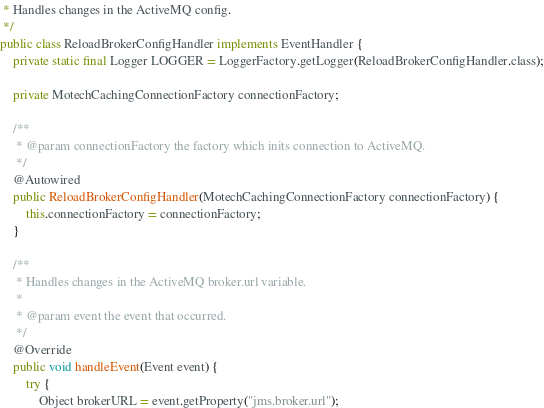<code> <loc_0><loc_0><loc_500><loc_500><_Java_> * Handles changes in the ActiveMQ config.
 */
public class ReloadBrokerConfigHandler implements EventHandler {
    private static final Logger LOGGER = LoggerFactory.getLogger(ReloadBrokerConfigHandler.class);

    private MotechCachingConnectionFactory connectionFactory;

    /**
     * @param connectionFactory the factory which inits connection to ActiveMQ.
     */
    @Autowired
    public ReloadBrokerConfigHandler(MotechCachingConnectionFactory connectionFactory) {
        this.connectionFactory = connectionFactory;
    }

    /**
     * Handles changes in the ActiveMQ broker.url variable.
     *
     * @param event the event that occurred.
     */
    @Override
    public void handleEvent(Event event) {
        try {
            Object brokerURL = event.getProperty("jms.broker.url");
</code> 